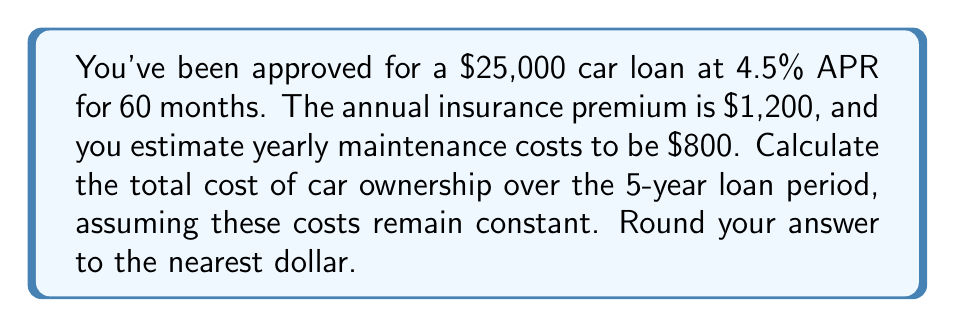Can you solve this math problem? Let's break this down step-by-step:

1. Loan payments:
   To calculate the monthly loan payment, we use the formula:
   $$ P = L \frac{r(1+r)^n}{(1+r)^n - 1} $$
   Where:
   $P$ = monthly payment
   $L$ = loan amount ($25,000)
   $r$ = monthly interest rate (4.5% / 12 = 0.375% = 0.00375)
   $n$ = number of months (60)

   $$ P = 25000 \frac{0.00375(1+0.00375)^{60}}{(1+0.00375)^{60} - 1} \approx 466.08 $$

   Monthly payment = $466.08
   Total loan payments over 5 years = $466.08 * 60 = $27,964.80

2. Insurance costs:
   Annual insurance premium = $1,200
   Total insurance cost over 5 years = $1,200 * 5 = $6,000

3. Maintenance costs:
   Annual maintenance cost = $800
   Total maintenance cost over 5 years = $800 * 5 = $4,000

4. Total cost of ownership:
   Sum of loan payments, insurance, and maintenance
   $27,964.80 + $6,000 + $4,000 = $37,964.80

Rounding to the nearest dollar: $37,965
Answer: $37,965 